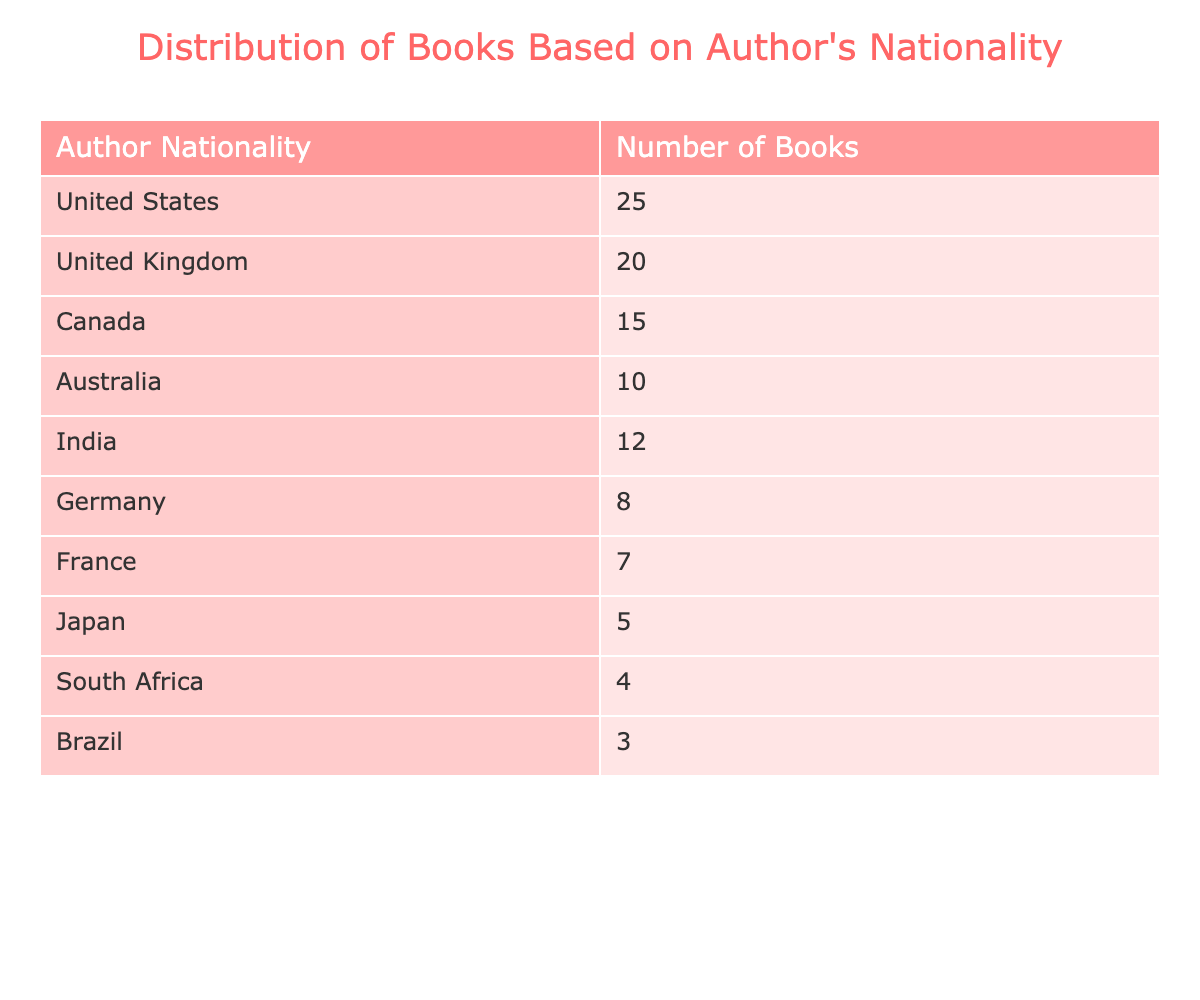What nationality has the highest number of books? The table shows that the United States has the highest number of books at 25.
Answer: United States How many books are authored by writers from India? From the table, the number of books authored by writers from India is 12.
Answer: 12 What is the total number of books from Canada and Australia combined? The number of books from Canada is 15 and from Australia is 10. Adding these together gives 15 + 10 = 25.
Answer: 25 Is there more representation from the United Kingdom or Germany? The table shows 20 books from the United Kingdom and 8 books from Germany. Since 20 is greater than 8, the United Kingdom has more representation.
Answer: Yes What is the average number of books per nationality shown in this table? There are 10 nationalities listed in the table. The total number of books is 25 + 20 + 15 + 10 + 12 + 8 + 7 + 5 + 4 + 3 = 109. Dividing the total by the number of nationalities gives 109 / 10 = 10.9.
Answer: 10.9 Which nationality contributes the least number of books? Looking at the table, Brazil has the least number of books, with a total of 3.
Answer: Brazil If we categorize the authors into two groups: one group with more than 10 books and another with 10 or fewer, how many authors are in each group? Authors with more than 10 books include the United States, United Kingdom, Canada, Australia, and India, totaling 5 authors. Authors with 10 or fewer books are Germany, France, Japan, South Africa, and Brazil, totaling 5 authors.
Answer: 5 in each group What is the difference in the number of books between the authors from the United States and South Africa? The United States has 25 books, while South Africa has 4 books. The difference is 25 - 4 = 21.
Answer: 21 Are there more books attributed to authors from Japan than those from South Africa? Japan has 5 books and South Africa has 4 books. Since 5 is greater than 4, there are more books from Japan.
Answer: Yes 